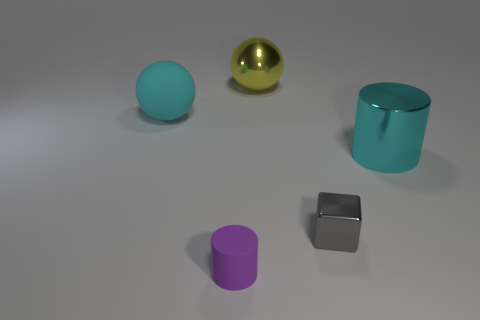Subtract all cyan spheres. How many spheres are left? 1 Add 2 tiny purple cubes. How many objects exist? 7 Subtract all cubes. How many objects are left? 4 Add 5 matte cylinders. How many matte cylinders are left? 6 Add 4 spheres. How many spheres exist? 6 Subtract 0 yellow blocks. How many objects are left? 5 Subtract all red cubes. Subtract all red spheres. How many cubes are left? 1 Subtract all cyan matte balls. Subtract all cyan spheres. How many objects are left? 3 